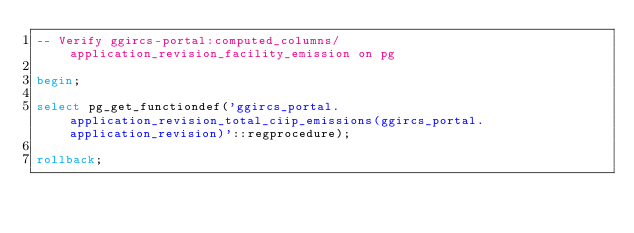Convert code to text. <code><loc_0><loc_0><loc_500><loc_500><_SQL_>-- Verify ggircs-portal:computed_columns/application_revision_facility_emission on pg

begin;

select pg_get_functiondef('ggircs_portal.application_revision_total_ciip_emissions(ggircs_portal.application_revision)'::regprocedure);

rollback;
</code> 